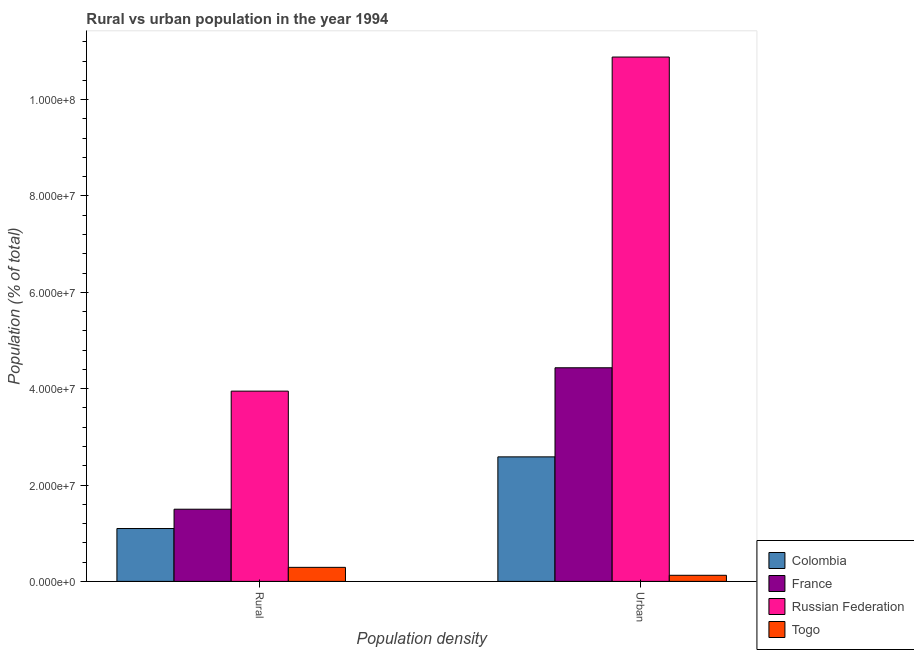How many different coloured bars are there?
Ensure brevity in your answer.  4. How many groups of bars are there?
Give a very brief answer. 2. How many bars are there on the 1st tick from the left?
Provide a succinct answer. 4. How many bars are there on the 2nd tick from the right?
Give a very brief answer. 4. What is the label of the 1st group of bars from the left?
Keep it short and to the point. Rural. What is the rural population density in Togo?
Give a very brief answer. 2.91e+06. Across all countries, what is the maximum urban population density?
Offer a very short reply. 1.09e+08. Across all countries, what is the minimum urban population density?
Offer a terse response. 1.27e+06. In which country was the rural population density maximum?
Your response must be concise. Russian Federation. In which country was the rural population density minimum?
Ensure brevity in your answer.  Togo. What is the total rural population density in the graph?
Your response must be concise. 6.84e+07. What is the difference between the rural population density in Togo and that in Russian Federation?
Your answer should be compact. -3.66e+07. What is the difference between the urban population density in Colombia and the rural population density in France?
Keep it short and to the point. 1.09e+07. What is the average rural population density per country?
Offer a very short reply. 1.71e+07. What is the difference between the rural population density and urban population density in France?
Provide a short and direct response. -2.94e+07. What is the ratio of the urban population density in Colombia to that in Togo?
Make the answer very short. 20.42. In how many countries, is the urban population density greater than the average urban population density taken over all countries?
Keep it short and to the point. 1. What does the 2nd bar from the left in Urban represents?
Keep it short and to the point. France. What does the 2nd bar from the right in Rural represents?
Offer a very short reply. Russian Federation. How many bars are there?
Provide a short and direct response. 8. Are the values on the major ticks of Y-axis written in scientific E-notation?
Make the answer very short. Yes. Does the graph contain grids?
Provide a short and direct response. No. Where does the legend appear in the graph?
Provide a short and direct response. Bottom right. How are the legend labels stacked?
Give a very brief answer. Vertical. What is the title of the graph?
Offer a terse response. Rural vs urban population in the year 1994. What is the label or title of the X-axis?
Make the answer very short. Population density. What is the label or title of the Y-axis?
Your answer should be compact. Population (% of total). What is the Population (% of total) of Colombia in Rural?
Your answer should be compact. 1.10e+07. What is the Population (% of total) in France in Rural?
Keep it short and to the point. 1.50e+07. What is the Population (% of total) in Russian Federation in Rural?
Your answer should be compact. 3.95e+07. What is the Population (% of total) of Togo in Rural?
Offer a terse response. 2.91e+06. What is the Population (% of total) of Colombia in Urban?
Your response must be concise. 2.58e+07. What is the Population (% of total) of France in Urban?
Your response must be concise. 4.43e+07. What is the Population (% of total) of Russian Federation in Urban?
Your answer should be compact. 1.09e+08. What is the Population (% of total) of Togo in Urban?
Give a very brief answer. 1.27e+06. Across all Population density, what is the maximum Population (% of total) of Colombia?
Your answer should be compact. 2.58e+07. Across all Population density, what is the maximum Population (% of total) in France?
Offer a terse response. 4.43e+07. Across all Population density, what is the maximum Population (% of total) of Russian Federation?
Provide a short and direct response. 1.09e+08. Across all Population density, what is the maximum Population (% of total) in Togo?
Your response must be concise. 2.91e+06. Across all Population density, what is the minimum Population (% of total) in Colombia?
Your answer should be very brief. 1.10e+07. Across all Population density, what is the minimum Population (% of total) in France?
Ensure brevity in your answer.  1.50e+07. Across all Population density, what is the minimum Population (% of total) in Russian Federation?
Your answer should be compact. 3.95e+07. Across all Population density, what is the minimum Population (% of total) in Togo?
Give a very brief answer. 1.27e+06. What is the total Population (% of total) of Colombia in the graph?
Ensure brevity in your answer.  3.68e+07. What is the total Population (% of total) in France in the graph?
Provide a short and direct response. 5.93e+07. What is the total Population (% of total) of Russian Federation in the graph?
Provide a short and direct response. 1.48e+08. What is the total Population (% of total) in Togo in the graph?
Your response must be concise. 4.18e+06. What is the difference between the Population (% of total) in Colombia in Rural and that in Urban?
Make the answer very short. -1.49e+07. What is the difference between the Population (% of total) of France in Rural and that in Urban?
Keep it short and to the point. -2.94e+07. What is the difference between the Population (% of total) in Russian Federation in Rural and that in Urban?
Make the answer very short. -6.94e+07. What is the difference between the Population (% of total) of Togo in Rural and that in Urban?
Make the answer very short. 1.65e+06. What is the difference between the Population (% of total) of Colombia in Rural and the Population (% of total) of France in Urban?
Give a very brief answer. -3.34e+07. What is the difference between the Population (% of total) in Colombia in Rural and the Population (% of total) in Russian Federation in Urban?
Your response must be concise. -9.79e+07. What is the difference between the Population (% of total) in Colombia in Rural and the Population (% of total) in Togo in Urban?
Your answer should be compact. 9.71e+06. What is the difference between the Population (% of total) in France in Rural and the Population (% of total) in Russian Federation in Urban?
Offer a very short reply. -9.39e+07. What is the difference between the Population (% of total) in France in Rural and the Population (% of total) in Togo in Urban?
Your response must be concise. 1.37e+07. What is the difference between the Population (% of total) of Russian Federation in Rural and the Population (% of total) of Togo in Urban?
Ensure brevity in your answer.  3.82e+07. What is the average Population (% of total) of Colombia per Population density?
Your answer should be compact. 1.84e+07. What is the average Population (% of total) in France per Population density?
Provide a succinct answer. 2.97e+07. What is the average Population (% of total) in Russian Federation per Population density?
Provide a succinct answer. 7.42e+07. What is the average Population (% of total) in Togo per Population density?
Your response must be concise. 2.09e+06. What is the difference between the Population (% of total) in Colombia and Population (% of total) in France in Rural?
Make the answer very short. -4.01e+06. What is the difference between the Population (% of total) in Colombia and Population (% of total) in Russian Federation in Rural?
Ensure brevity in your answer.  -2.85e+07. What is the difference between the Population (% of total) of Colombia and Population (% of total) of Togo in Rural?
Keep it short and to the point. 8.06e+06. What is the difference between the Population (% of total) of France and Population (% of total) of Russian Federation in Rural?
Offer a terse response. -2.45e+07. What is the difference between the Population (% of total) in France and Population (% of total) in Togo in Rural?
Your answer should be compact. 1.21e+07. What is the difference between the Population (% of total) in Russian Federation and Population (% of total) in Togo in Rural?
Keep it short and to the point. 3.66e+07. What is the difference between the Population (% of total) in Colombia and Population (% of total) in France in Urban?
Your response must be concise. -1.85e+07. What is the difference between the Population (% of total) of Colombia and Population (% of total) of Russian Federation in Urban?
Give a very brief answer. -8.30e+07. What is the difference between the Population (% of total) in Colombia and Population (% of total) in Togo in Urban?
Provide a short and direct response. 2.46e+07. What is the difference between the Population (% of total) of France and Population (% of total) of Russian Federation in Urban?
Give a very brief answer. -6.45e+07. What is the difference between the Population (% of total) in France and Population (% of total) in Togo in Urban?
Your answer should be very brief. 4.31e+07. What is the difference between the Population (% of total) in Russian Federation and Population (% of total) in Togo in Urban?
Keep it short and to the point. 1.08e+08. What is the ratio of the Population (% of total) in Colombia in Rural to that in Urban?
Your response must be concise. 0.42. What is the ratio of the Population (% of total) of France in Rural to that in Urban?
Your answer should be compact. 0.34. What is the ratio of the Population (% of total) in Russian Federation in Rural to that in Urban?
Keep it short and to the point. 0.36. What is the ratio of the Population (% of total) in Togo in Rural to that in Urban?
Your response must be concise. 2.3. What is the difference between the highest and the second highest Population (% of total) of Colombia?
Make the answer very short. 1.49e+07. What is the difference between the highest and the second highest Population (% of total) in France?
Ensure brevity in your answer.  2.94e+07. What is the difference between the highest and the second highest Population (% of total) of Russian Federation?
Make the answer very short. 6.94e+07. What is the difference between the highest and the second highest Population (% of total) of Togo?
Offer a very short reply. 1.65e+06. What is the difference between the highest and the lowest Population (% of total) of Colombia?
Provide a succinct answer. 1.49e+07. What is the difference between the highest and the lowest Population (% of total) in France?
Provide a short and direct response. 2.94e+07. What is the difference between the highest and the lowest Population (% of total) of Russian Federation?
Your response must be concise. 6.94e+07. What is the difference between the highest and the lowest Population (% of total) in Togo?
Offer a very short reply. 1.65e+06. 